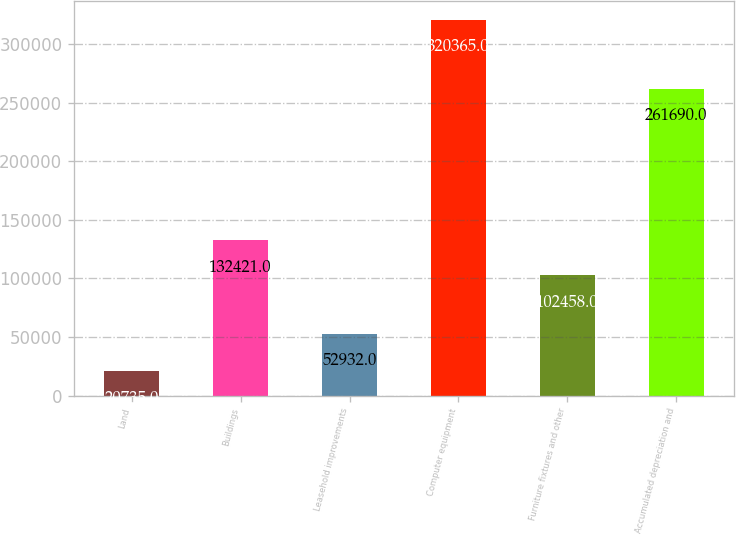Convert chart to OTSL. <chart><loc_0><loc_0><loc_500><loc_500><bar_chart><fcel>Land<fcel>Buildings<fcel>Leasehold improvements<fcel>Computer equipment<fcel>Furniture fixtures and other<fcel>Accumulated depreciation and<nl><fcel>20735<fcel>132421<fcel>52932<fcel>320365<fcel>102458<fcel>261690<nl></chart> 